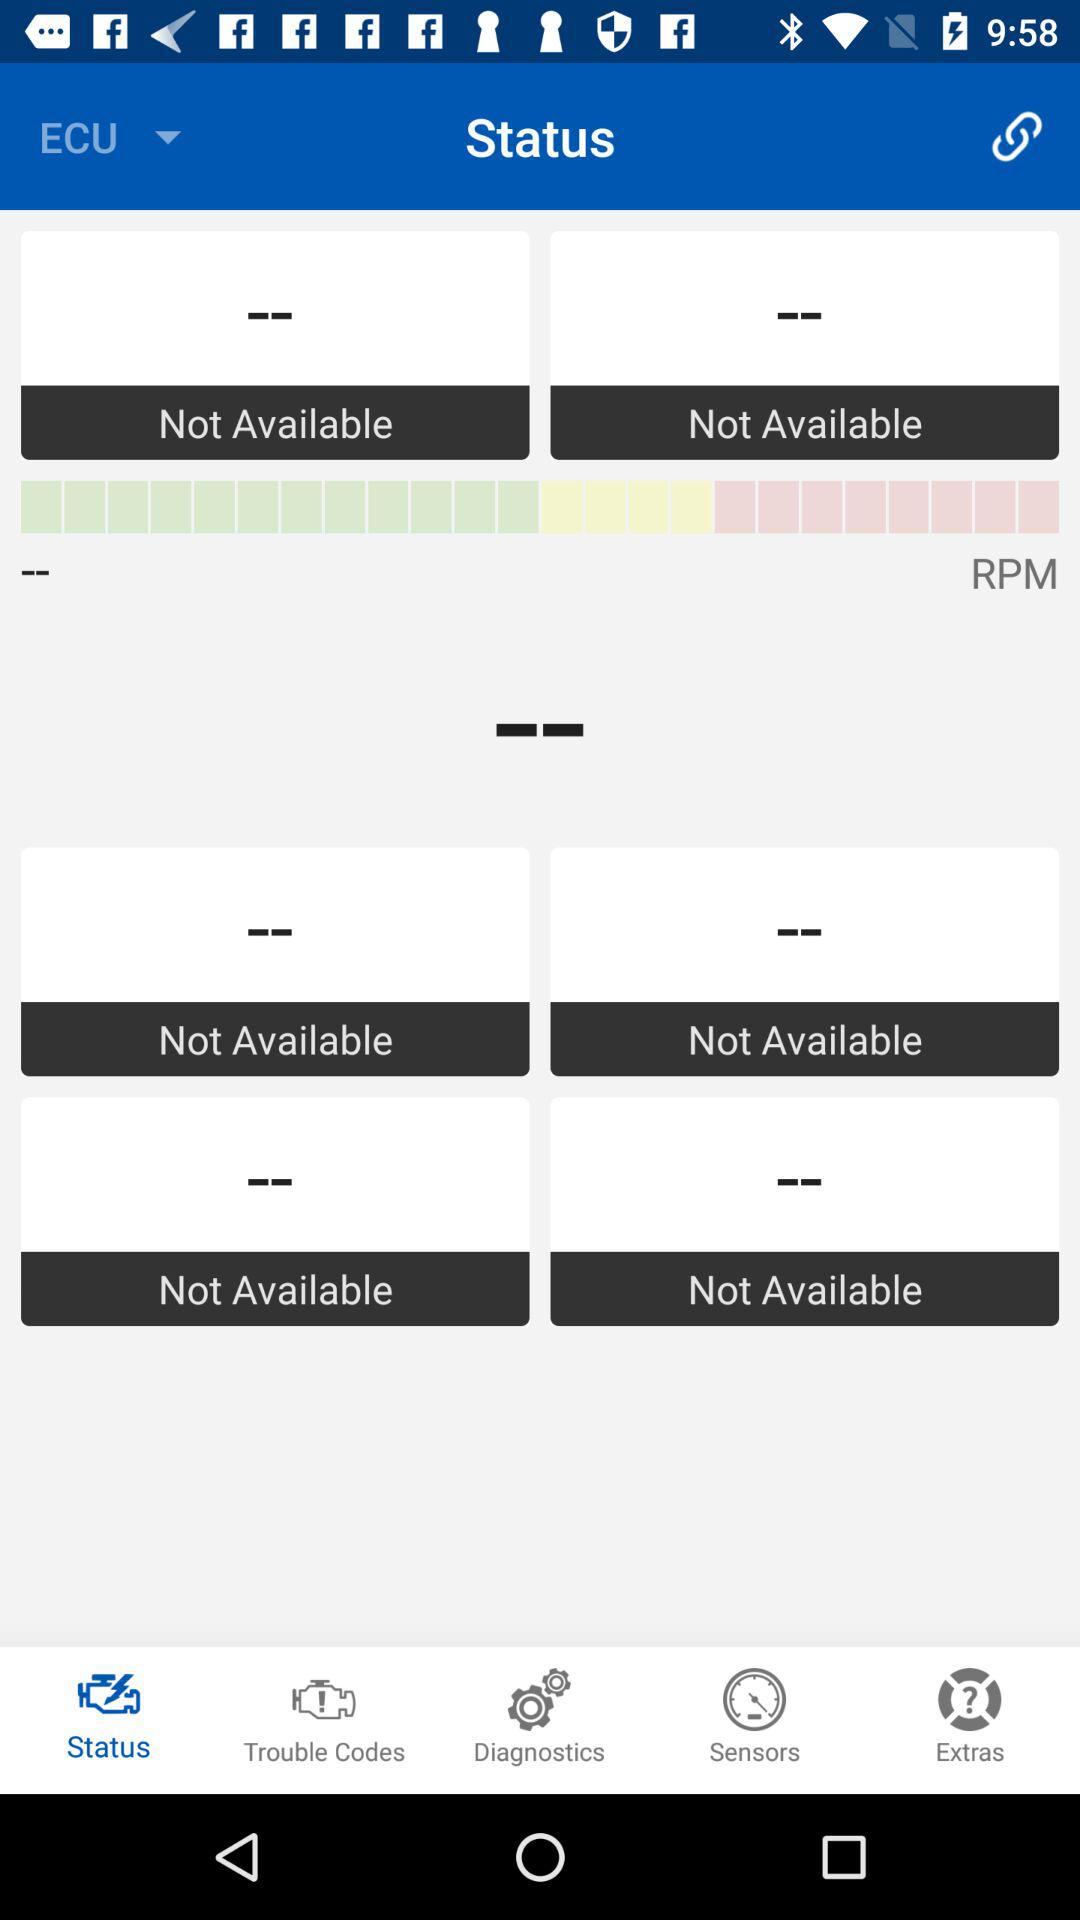Which tab is selected? The selected tab is "Status". 